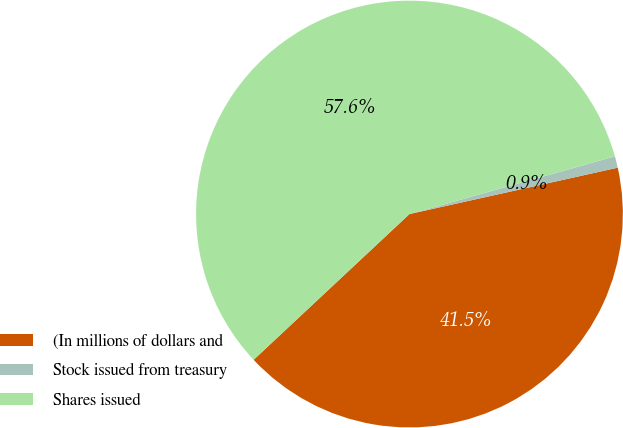Convert chart. <chart><loc_0><loc_0><loc_500><loc_500><pie_chart><fcel>(In millions of dollars and<fcel>Stock issued from treasury<fcel>Shares issued<nl><fcel>41.52%<fcel>0.87%<fcel>57.61%<nl></chart> 